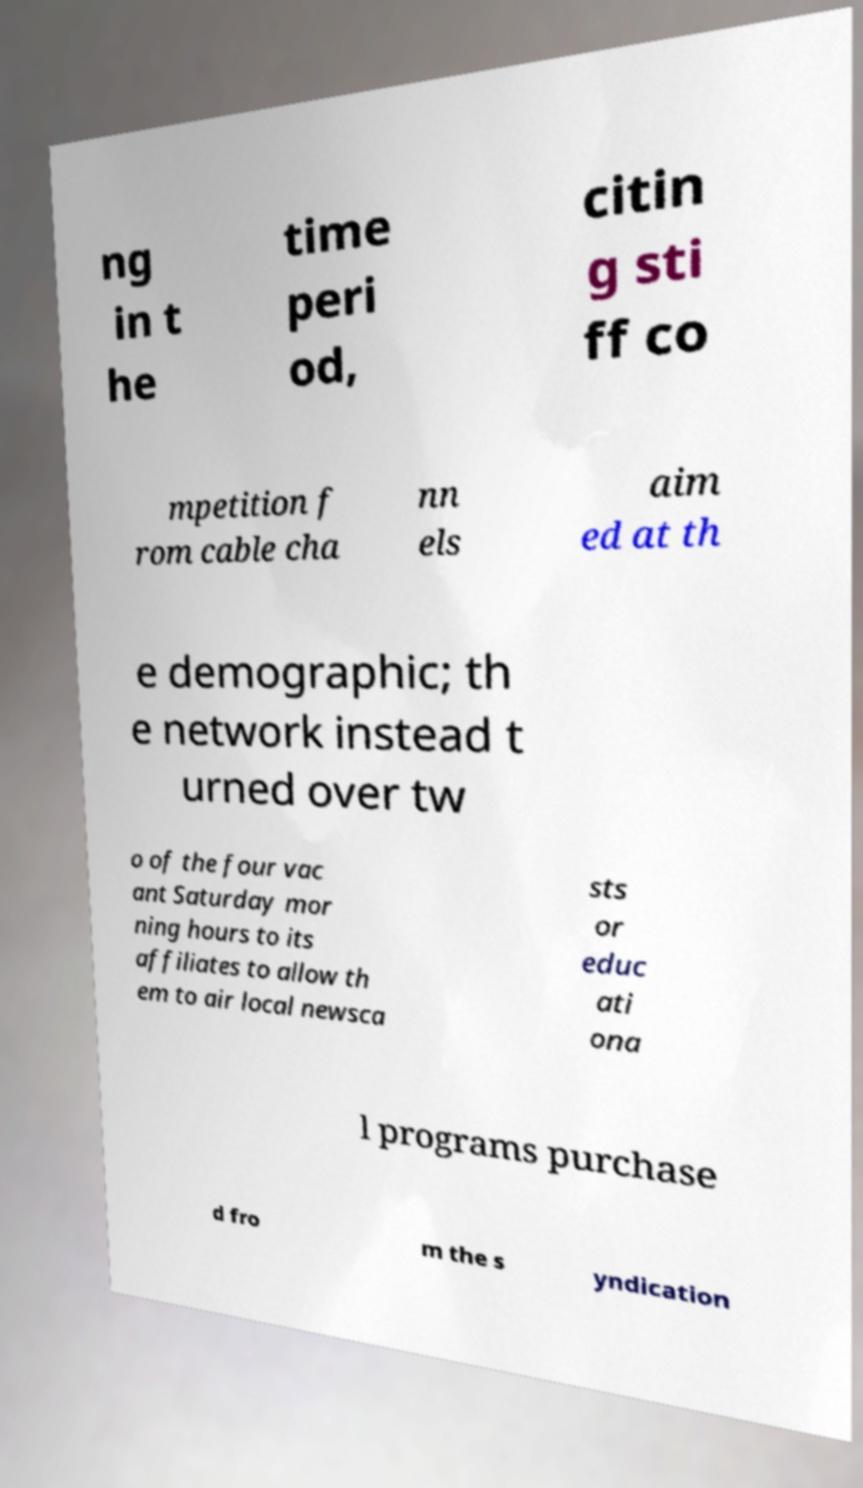What messages or text are displayed in this image? I need them in a readable, typed format. ng in t he time peri od, citin g sti ff co mpetition f rom cable cha nn els aim ed at th e demographic; th e network instead t urned over tw o of the four vac ant Saturday mor ning hours to its affiliates to allow th em to air local newsca sts or educ ati ona l programs purchase d fro m the s yndication 